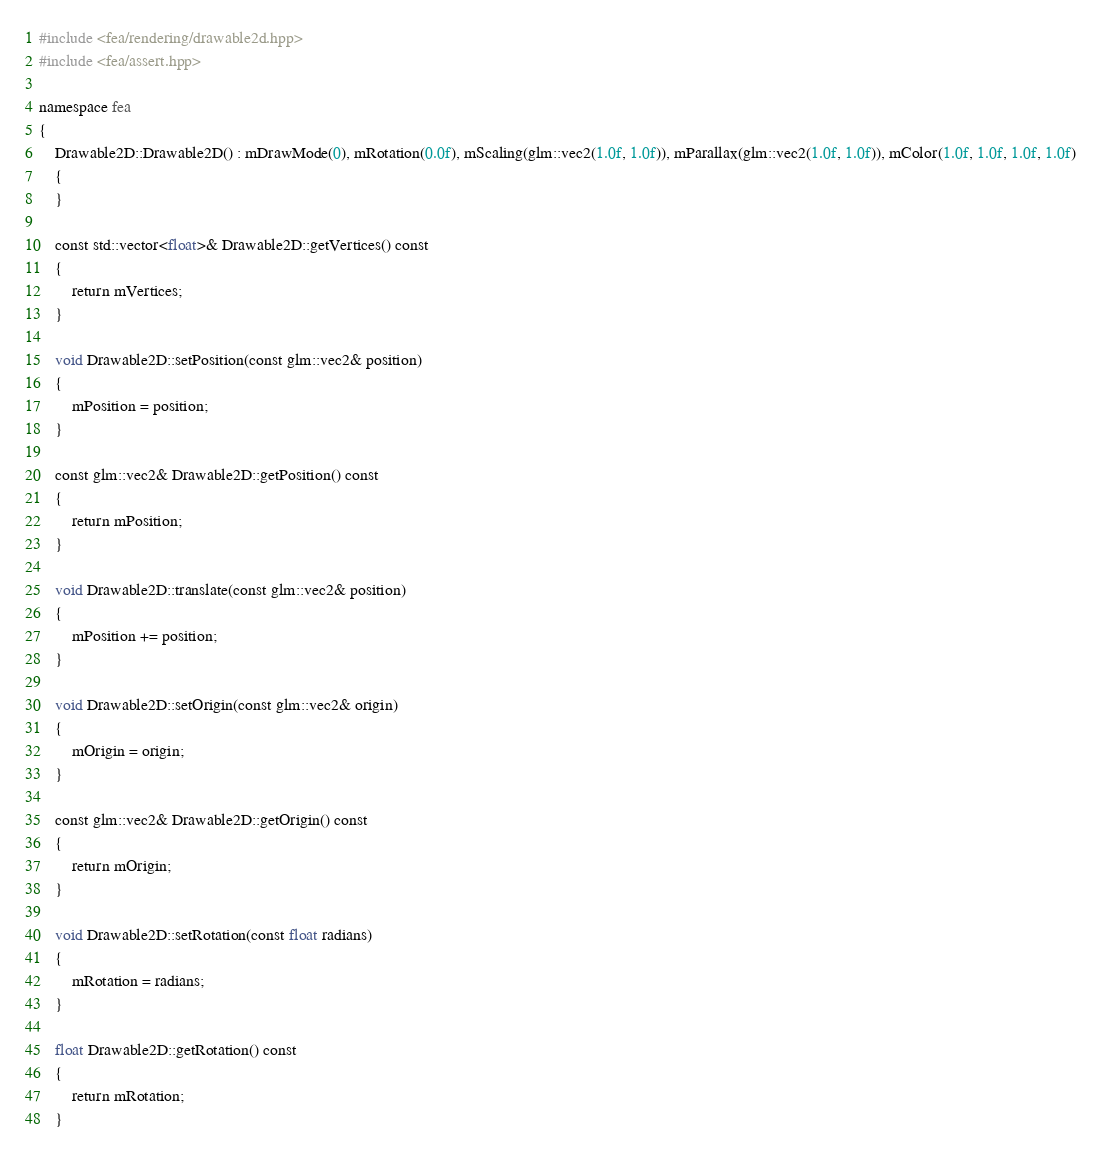<code> <loc_0><loc_0><loc_500><loc_500><_C++_>#include <fea/rendering/drawable2d.hpp>
#include <fea/assert.hpp>

namespace fea
{
    Drawable2D::Drawable2D() : mDrawMode(0), mRotation(0.0f), mScaling(glm::vec2(1.0f, 1.0f)), mParallax(glm::vec2(1.0f, 1.0f)), mColor(1.0f, 1.0f, 1.0f, 1.0f)
    {
    }

    const std::vector<float>& Drawable2D::getVertices() const
    {
        return mVertices;
    }
    
    void Drawable2D::setPosition(const glm::vec2& position)
    {
        mPosition = position;
    }
    
    const glm::vec2& Drawable2D::getPosition() const
    {
        return mPosition;
    }
    
    void Drawable2D::translate(const glm::vec2& position)
    {
        mPosition += position;
    }
    
    void Drawable2D::setOrigin(const glm::vec2& origin)
    {
        mOrigin = origin;
    }

    const glm::vec2& Drawable2D::getOrigin() const
    {
        return mOrigin;
    }

    void Drawable2D::setRotation(const float radians)
    {
        mRotation = radians;
    }
    
    float Drawable2D::getRotation() const
    {
        return mRotation;
    }
</code> 